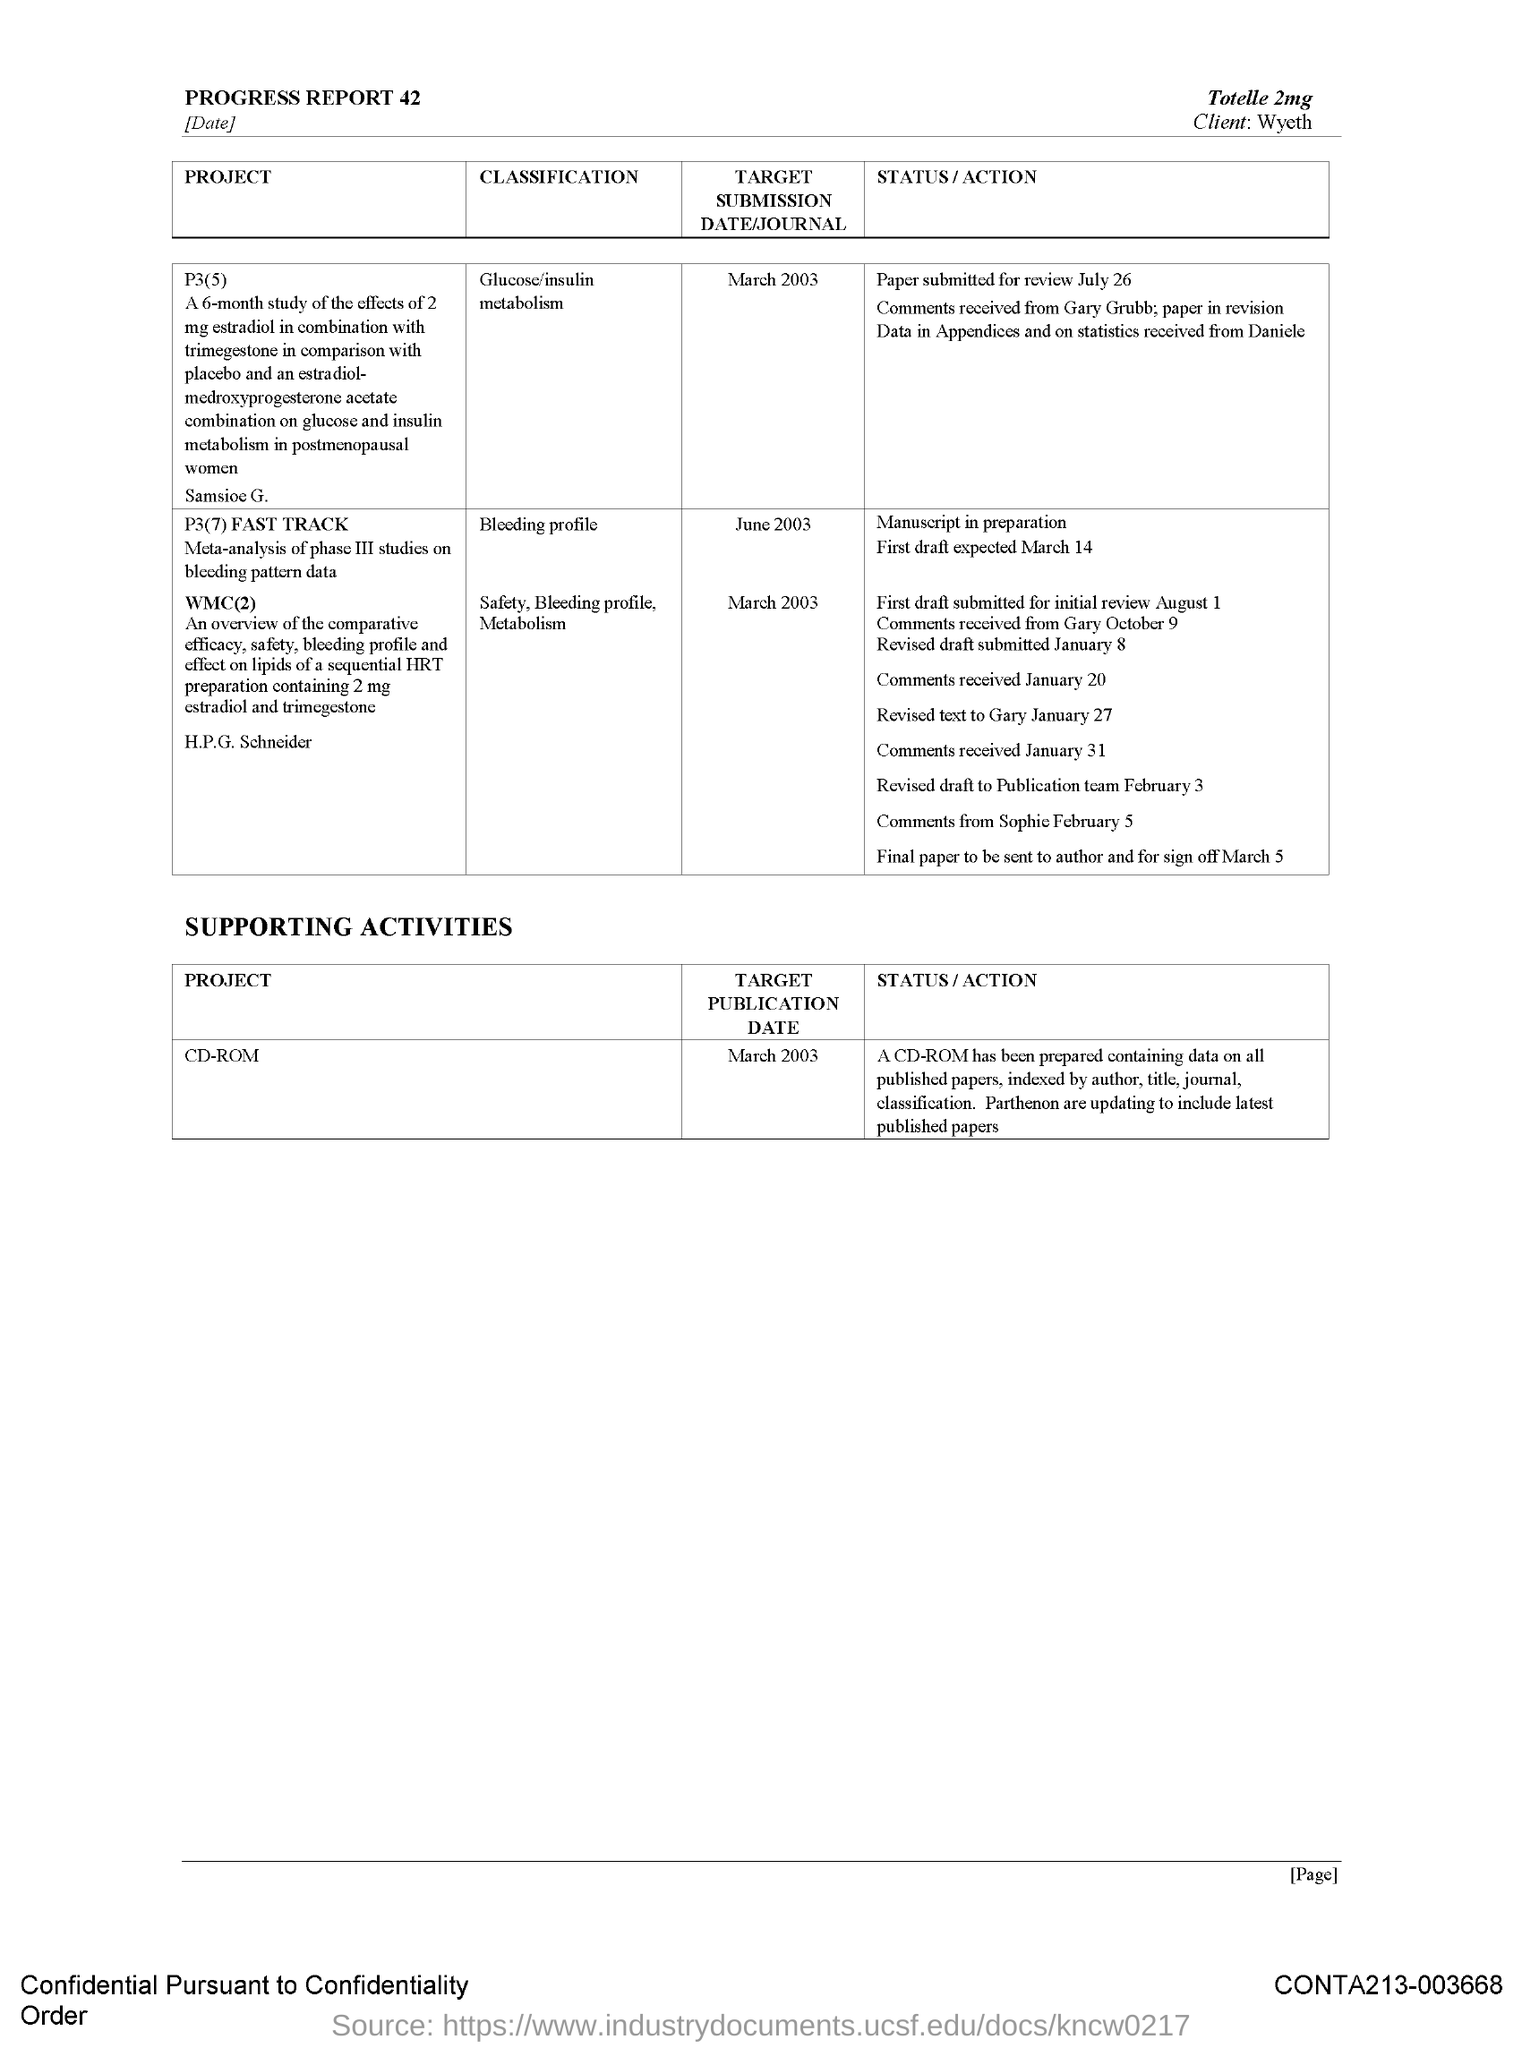Who is the client?
Your answer should be compact. Wyeth. What is the classification of the project P3(5)?
Offer a terse response. Glucose/insulin metabolism. When is the target submission date of WMC(2)?
Your answer should be very brief. March 2003. What is the status/action of P3(7)?
Make the answer very short. Manuscript in preparation. When is the target publication date of CD-ROM?
Your response must be concise. March 2003. 